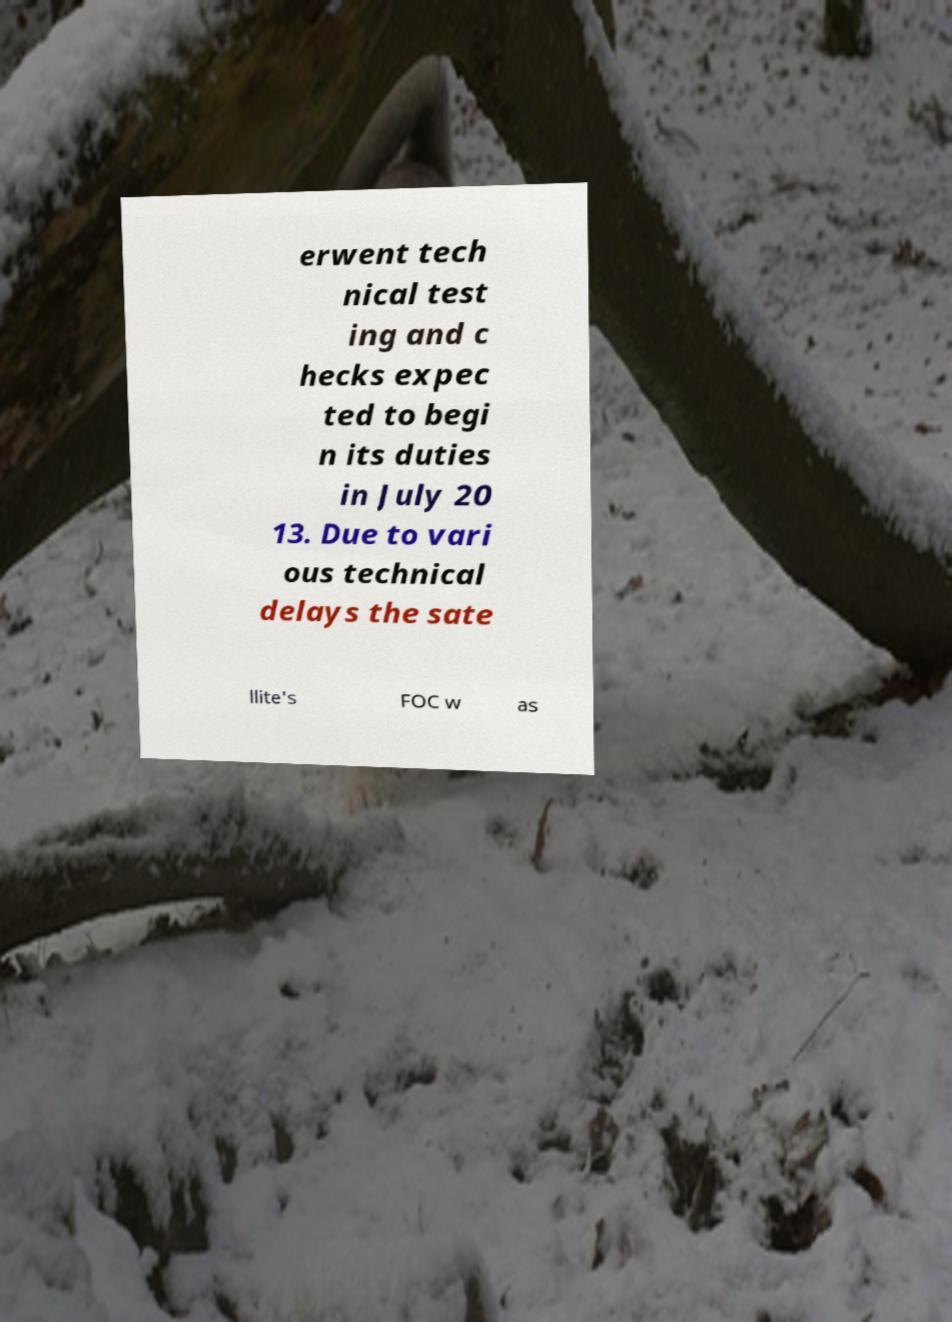Please read and relay the text visible in this image. What does it say? erwent tech nical test ing and c hecks expec ted to begi n its duties in July 20 13. Due to vari ous technical delays the sate llite's FOC w as 